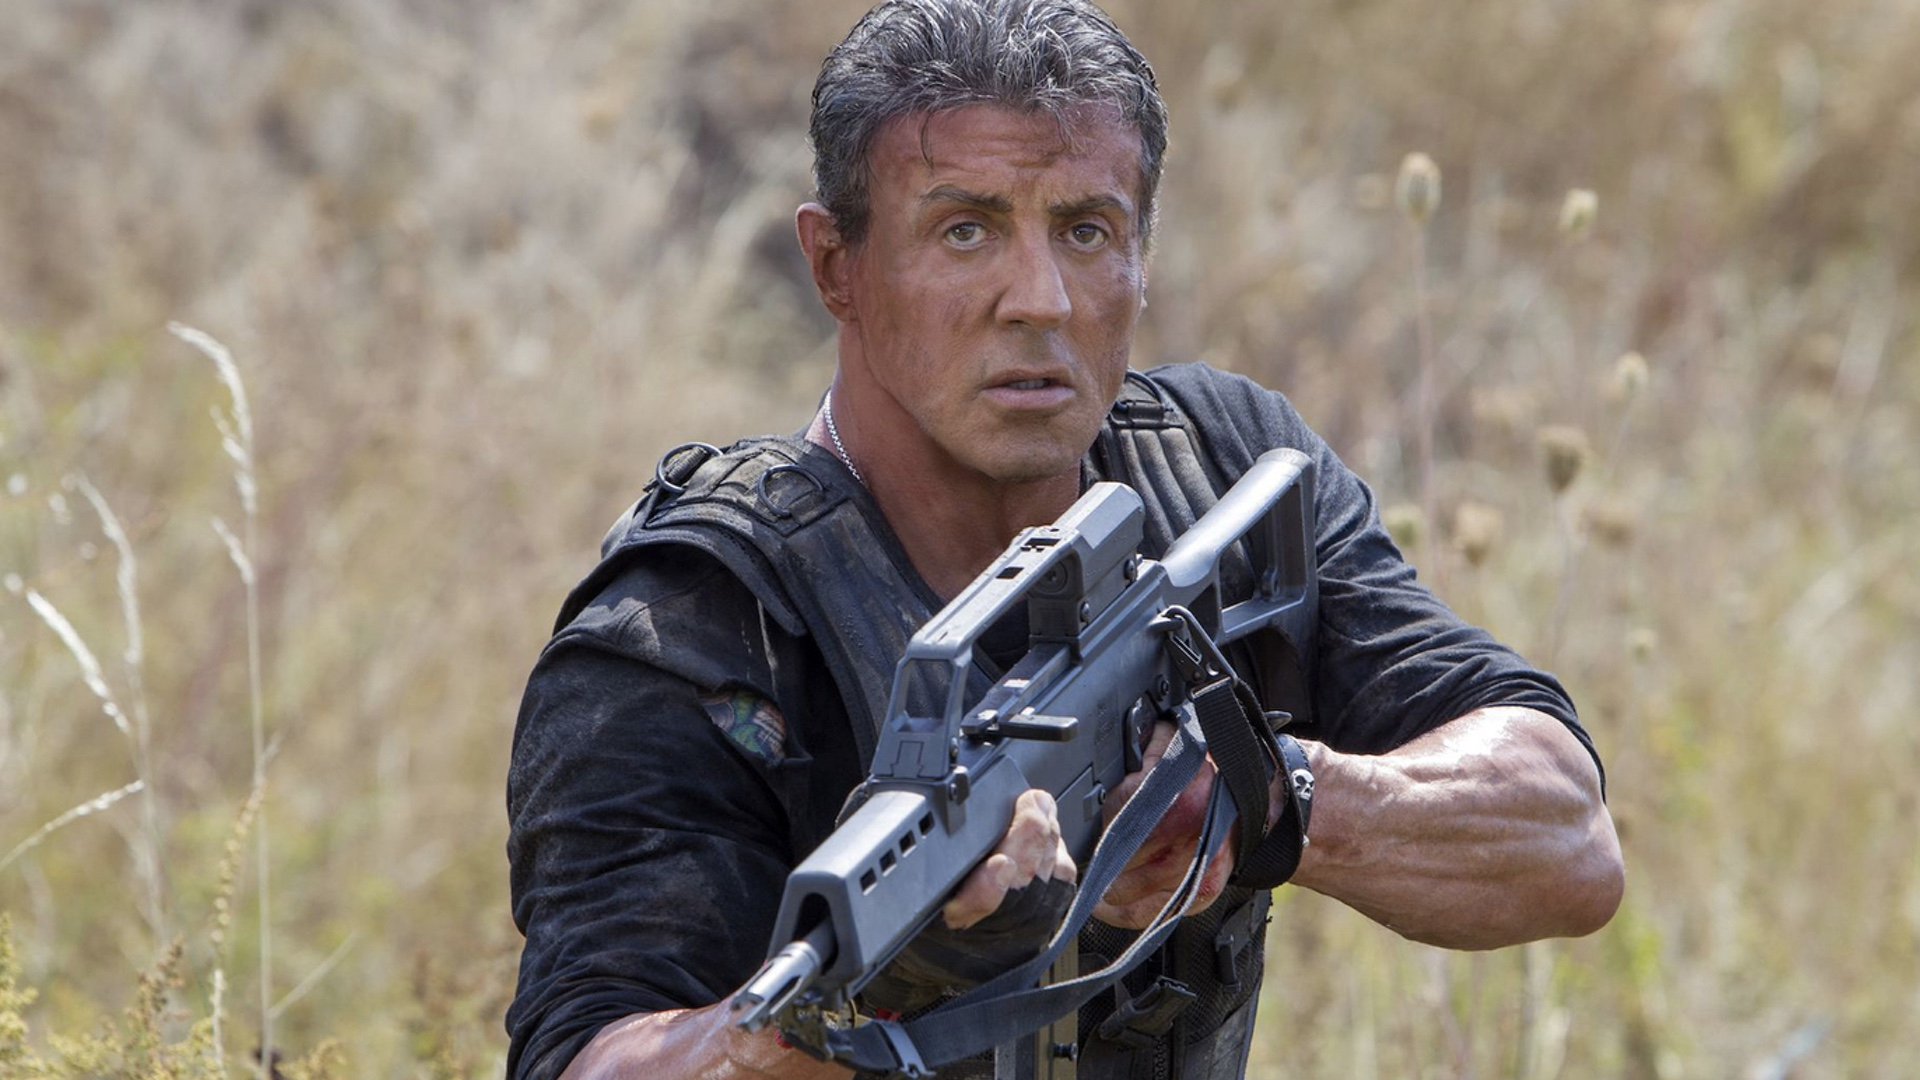Briefly explain a possible backstory for this scene. In the moments leading up to this scene, Rambo has been operating behind enemy lines, collecting vital intelligence to thwart an impending attack. This field is his chosen rendezvous point for extraction, but upon arrival, he realizes he's been followed and now must hold his ground until backup arrives. 